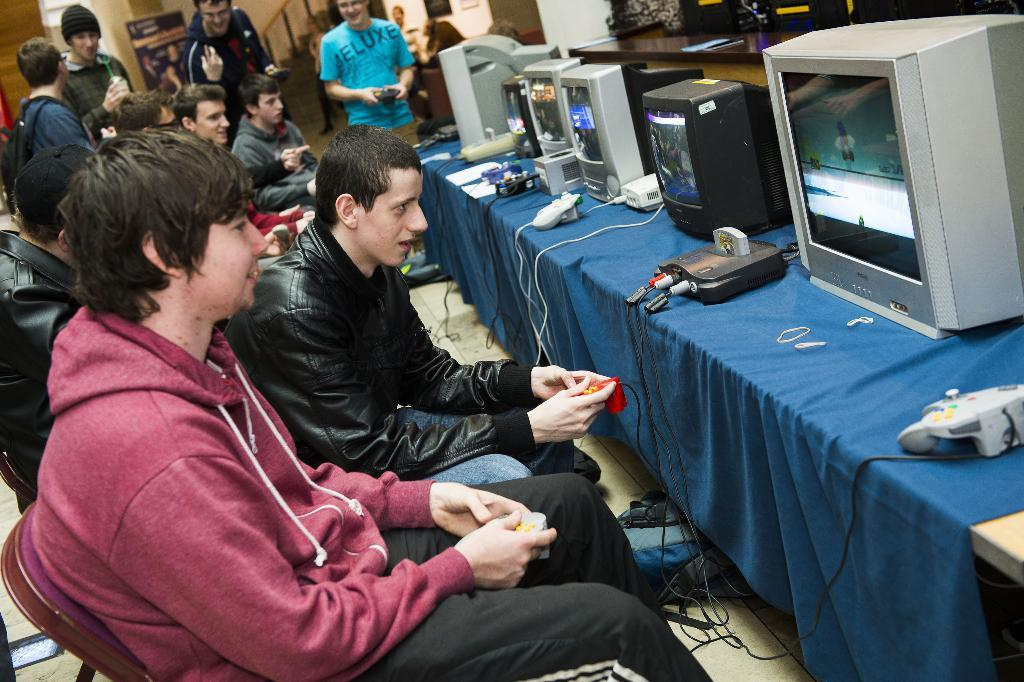What are the people in the image doing? The people in the image are sitting on chairs. What objects can be seen on the table in the image? There are computers visible in the image, and they are placed on a wooden table. What type of bushes can be seen in the image? There are no bushes present in the image. What is the reaction of the people sitting on chairs when they see a kiss in the image? There is no kiss present in the image, so it is not possible to determine the reaction of the people sitting on chairs. 